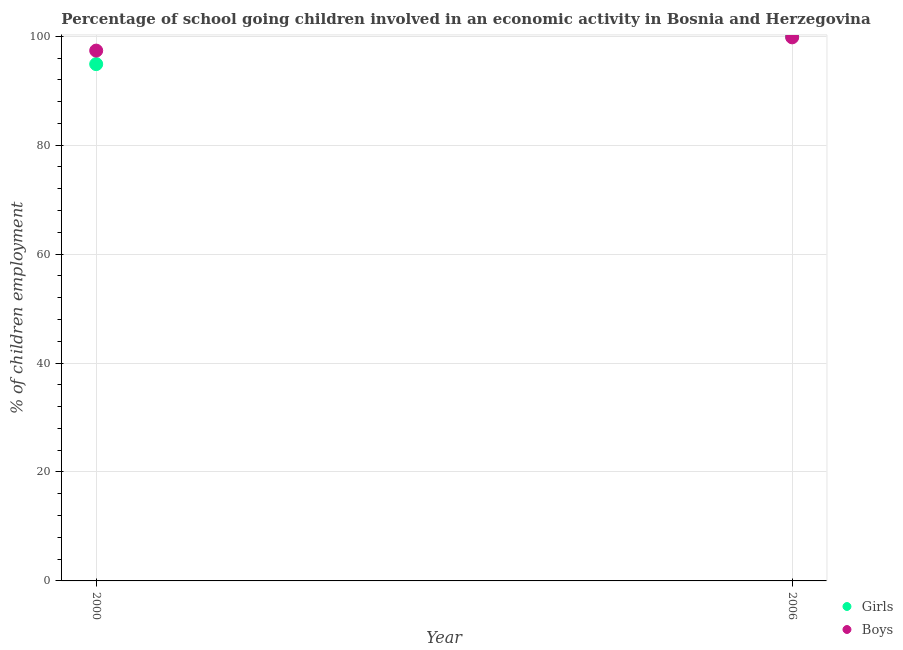How many different coloured dotlines are there?
Your response must be concise. 2. What is the percentage of school going girls in 2000?
Make the answer very short. 94.89. Across all years, what is the maximum percentage of school going boys?
Offer a very short reply. 99.8. Across all years, what is the minimum percentage of school going girls?
Your response must be concise. 94.89. What is the total percentage of school going boys in the graph?
Your answer should be compact. 197.17. What is the difference between the percentage of school going boys in 2000 and that in 2006?
Provide a succinct answer. -2.43. What is the difference between the percentage of school going boys in 2006 and the percentage of school going girls in 2000?
Make the answer very short. 4.91. What is the average percentage of school going boys per year?
Give a very brief answer. 98.58. In the year 2006, what is the difference between the percentage of school going boys and percentage of school going girls?
Keep it short and to the point. -0.2. What is the ratio of the percentage of school going girls in 2000 to that in 2006?
Keep it short and to the point. 0.95. Is the percentage of school going girls in 2000 less than that in 2006?
Offer a very short reply. Yes. In how many years, is the percentage of school going girls greater than the average percentage of school going girls taken over all years?
Ensure brevity in your answer.  1. Is the percentage of school going girls strictly greater than the percentage of school going boys over the years?
Offer a very short reply. No. Is the percentage of school going boys strictly less than the percentage of school going girls over the years?
Keep it short and to the point. No. How many years are there in the graph?
Offer a terse response. 2. Does the graph contain any zero values?
Keep it short and to the point. No. What is the title of the graph?
Your answer should be very brief. Percentage of school going children involved in an economic activity in Bosnia and Herzegovina. Does "Primary" appear as one of the legend labels in the graph?
Provide a short and direct response. No. What is the label or title of the X-axis?
Your response must be concise. Year. What is the label or title of the Y-axis?
Keep it short and to the point. % of children employment. What is the % of children employment of Girls in 2000?
Your response must be concise. 94.89. What is the % of children employment in Boys in 2000?
Provide a short and direct response. 97.37. What is the % of children employment in Boys in 2006?
Give a very brief answer. 99.8. Across all years, what is the maximum % of children employment of Girls?
Offer a very short reply. 100. Across all years, what is the maximum % of children employment in Boys?
Make the answer very short. 99.8. Across all years, what is the minimum % of children employment in Girls?
Your answer should be compact. 94.89. Across all years, what is the minimum % of children employment in Boys?
Offer a terse response. 97.37. What is the total % of children employment in Girls in the graph?
Offer a terse response. 194.89. What is the total % of children employment in Boys in the graph?
Provide a succinct answer. 197.17. What is the difference between the % of children employment in Girls in 2000 and that in 2006?
Offer a very short reply. -5.11. What is the difference between the % of children employment of Boys in 2000 and that in 2006?
Your answer should be very brief. -2.43. What is the difference between the % of children employment in Girls in 2000 and the % of children employment in Boys in 2006?
Offer a very short reply. -4.91. What is the average % of children employment of Girls per year?
Your response must be concise. 97.44. What is the average % of children employment of Boys per year?
Give a very brief answer. 98.58. In the year 2000, what is the difference between the % of children employment in Girls and % of children employment in Boys?
Keep it short and to the point. -2.48. In the year 2006, what is the difference between the % of children employment of Girls and % of children employment of Boys?
Your response must be concise. 0.2. What is the ratio of the % of children employment of Girls in 2000 to that in 2006?
Provide a short and direct response. 0.95. What is the ratio of the % of children employment of Boys in 2000 to that in 2006?
Ensure brevity in your answer.  0.98. What is the difference between the highest and the second highest % of children employment in Girls?
Keep it short and to the point. 5.11. What is the difference between the highest and the second highest % of children employment of Boys?
Provide a succinct answer. 2.43. What is the difference between the highest and the lowest % of children employment of Girls?
Give a very brief answer. 5.11. What is the difference between the highest and the lowest % of children employment in Boys?
Your answer should be very brief. 2.43. 